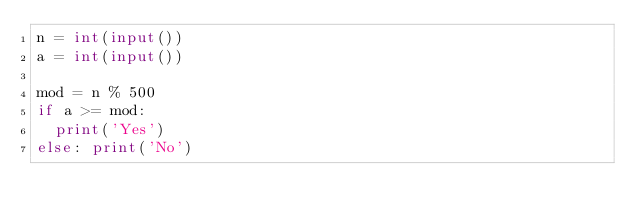Convert code to text. <code><loc_0><loc_0><loc_500><loc_500><_Python_>n = int(input())
a = int(input())

mod = n % 500
if a >= mod:
  print('Yes')
else: print('No')</code> 